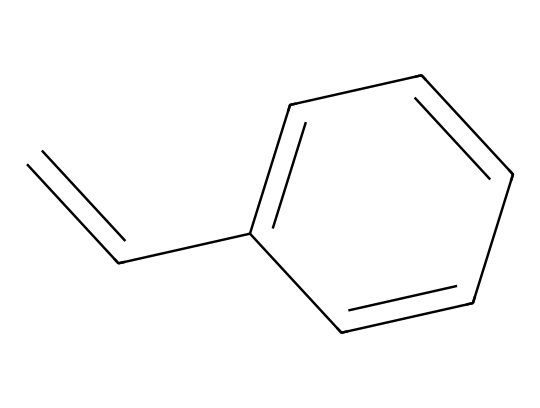How many carbon atoms are in the monomer structure of styrene? The SMILES representation indicates the presence of carbon atoms. Count the "C" symbols in the string, which results in a total of 8 carbon atoms.
Answer: 8 What type of chemical bond connects the carbon atoms in styrene? The structure shows double bonds between some of the carbon atoms (indicated by the "=" sign). Thus, styrene contains both single and double bonds.
Answer: single and double What is the functional group present in styrene? Looking at the structure, the presence of a vinyl group (C=CH2) indicates it is an alkene. Therefore, the functional group in styrene is a vinyl group.
Answer: vinyl group What is the geometric feature of the double bond in styrene? The presence of a double bond introduces rigidity, leading to a planar structure across the double-bonded carbon atoms. This results in a linear arrangement around the double bond.
Answer: planar How many rings are present in the structure of styrene? The structure does not display any closed loops or rings; therefore, there are zero rings present in styrene's structure.
Answer: 0 What type of polymer does styrene produce? When styrene undergoes polymerization, it forms polystyrene, which is a common thermoplastic polymer used in insulation materials.
Answer: polystyrene What is the aromatic feature in styrene? The chemical structure contains a benzene ring (C1=CC=CC=C1), which contributes to its aromaticity and stability. This indicates that styrene has aromatic characteristics due to the cyclic structure of the benzene.
Answer: benzene ring 